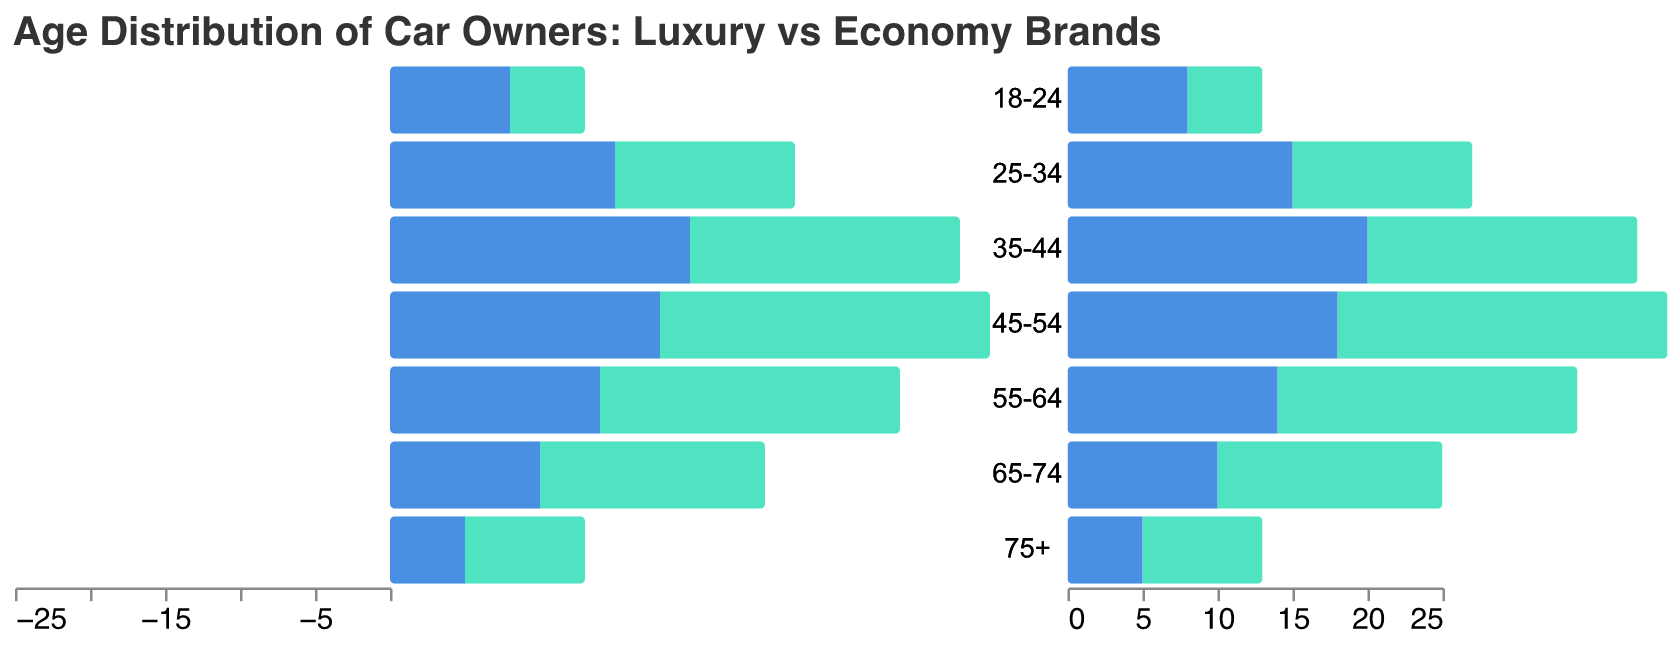What is the title of the chart? The title can be located at the top of the chart and spans across it, providing the audience with an immediate understanding of what the chart represents.
Answer: Age Distribution of Car Owners: Luxury vs Economy Brands Which age group has the highest number of owners for Luxury Brands? To find this, look for the longest bar stretching to the left in the section for Luxury Brands.
Answer: 45-54 What are the color representations for Luxury and Economy Brands? The legend at the bottom right of the chart provides color information. Luxury Brands use blue (#4a90e2) and Economy Brands use green (#50e3c2).
Answer: Blue for Luxury Brands, Green for Economy Brands How many more Economy car owners are there in the 25-34 age group compared to Luxury car owners in the same age group? Locate the bars for the 25-34 age group and compare the lengths. For Economy Brands, the number is 15, and for Luxury Brands, it is -12. Calculating the difference: 15 - (-12) = 27.
Answer: 27 Which brand has more owners aged 65-74? Compare the lengths of the bars corresponding to 65-74 in both sections. The Economy Brands bar (10) is longer than the Luxury Brands bar (-15).
Answer: Economy Brands Which age group has the smallest number of Economy car owners? Find the shortest bar in the section for Economy Brands. This corresponds to the 75+ age group, which has a value of 5.
Answer: 75+ What is the total number of Luxury car owners aged 55-74? Add the number of Luxury car owners in the 55-64 age group (-20) to the number in the 65-74 age group (-15): -20 + (-15) = -35.
Answer: -35 How many more Luxury car owners are there in the 35-44 age group than in the 18-24 age group? The number for Luxury Owners in the 35-44 age group is -18 and for the 18-24 age group is -5. Calculating the difference: -18 - (-5) = -13.
Answer: -13 What is the trend in the number of luxury car owners as age increases? Observing the bars in the Luxury Brands section from top to bottom, the numbers generally become more negative, indicating a higher number of owners in older age groups.
Answer: Increase in number Do any age groups have an equal number of owners for both Luxury and Economy Brands? By checking each age group separately, it can be confirmed that no age groups have equal numbers of owners between the two brands.
Answer: No 